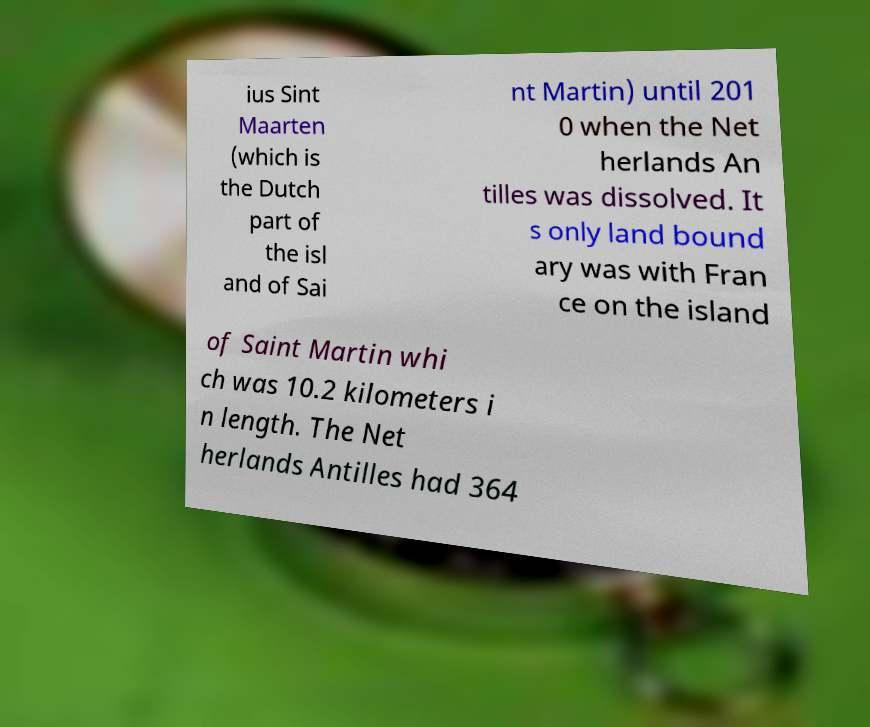Can you read and provide the text displayed in the image?This photo seems to have some interesting text. Can you extract and type it out for me? ius Sint Maarten (which is the Dutch part of the isl and of Sai nt Martin) until 201 0 when the Net herlands An tilles was dissolved. It s only land bound ary was with Fran ce on the island of Saint Martin whi ch was 10.2 kilometers i n length. The Net herlands Antilles had 364 